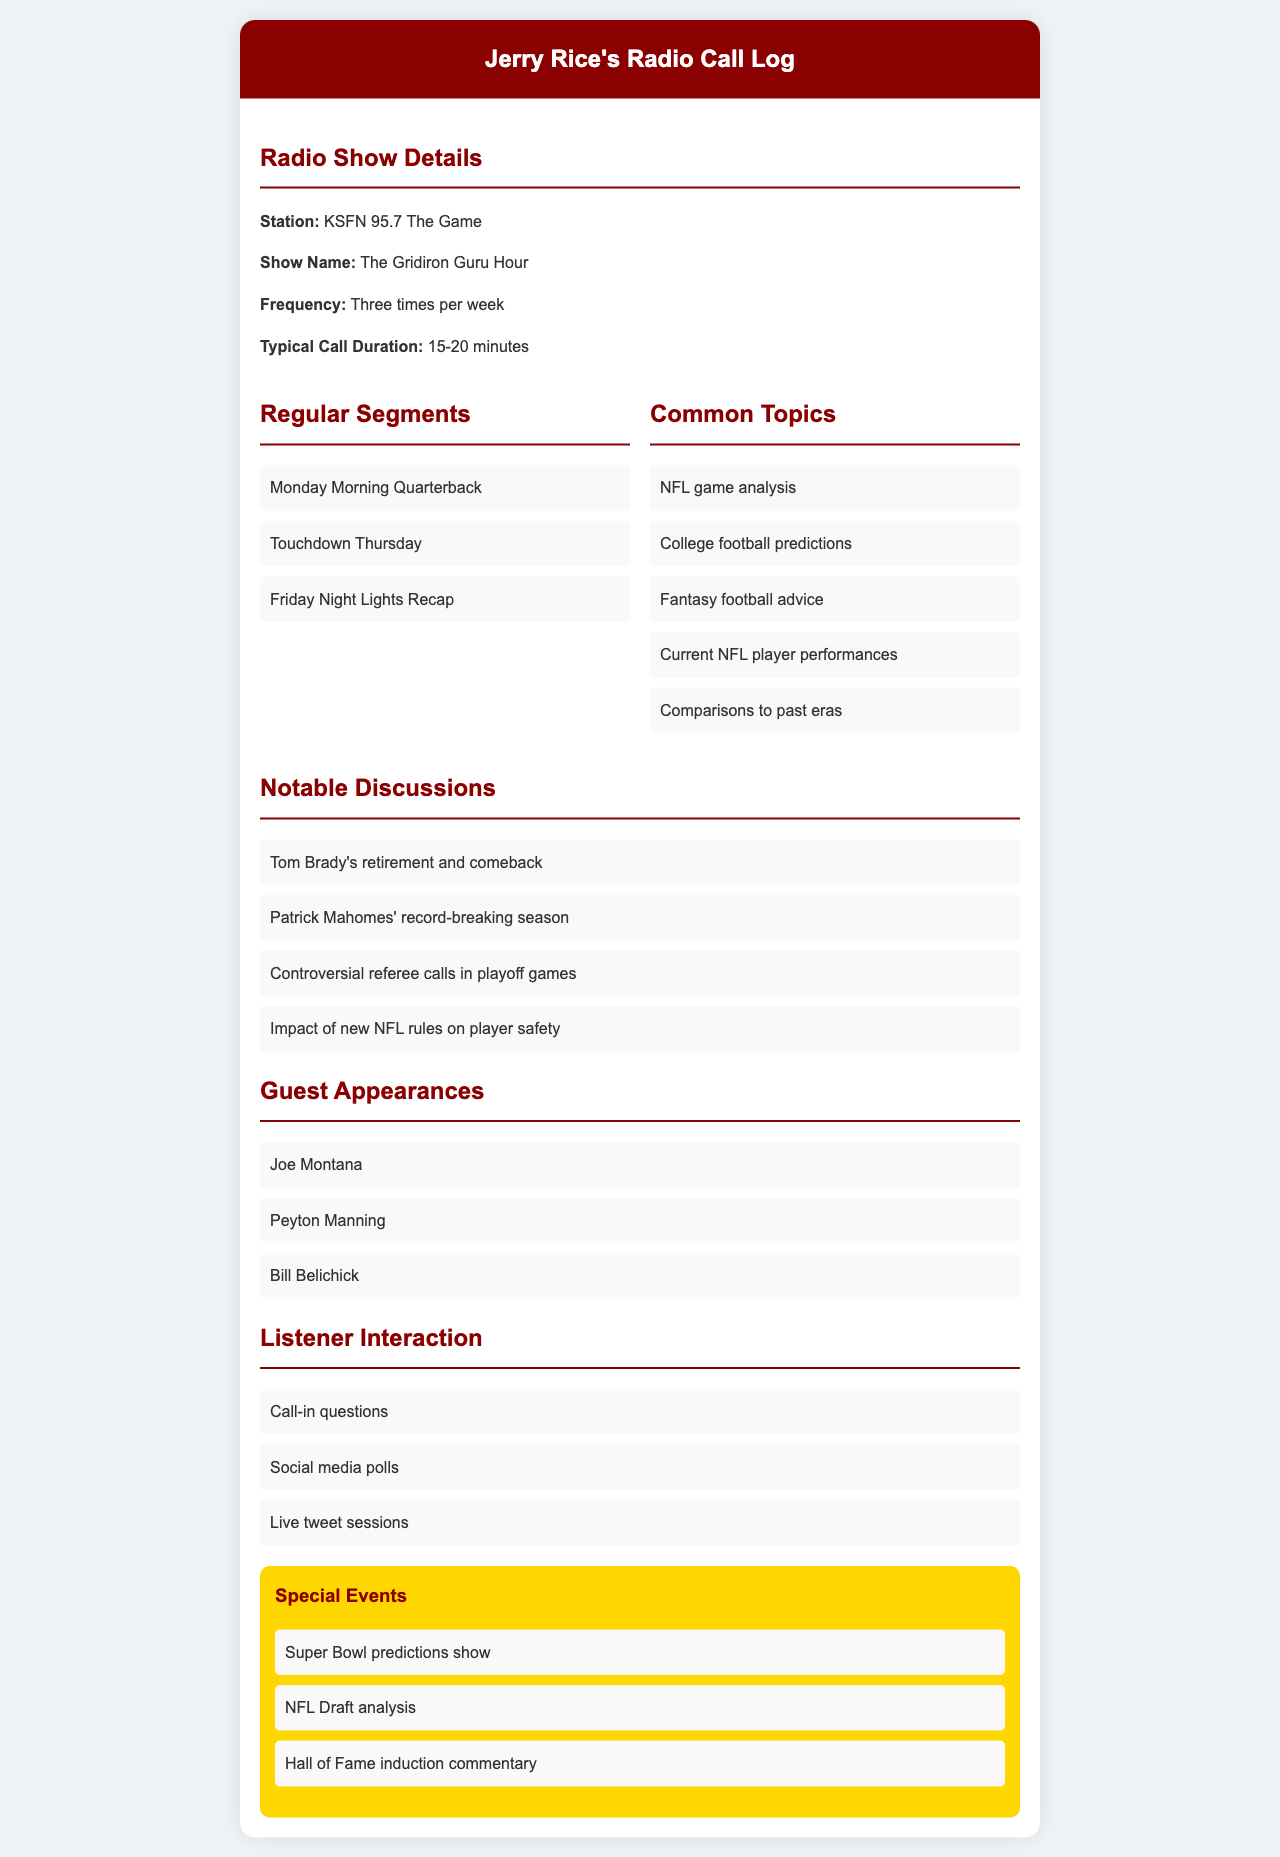What is the name of the radio station? The radio station name is listed prominently in the document.
Answer: KSFN 95.7 The Game How many times per week does the show air? The document states the frequency of the show clearly.
Answer: Three times per week What is the typical call duration? The document provides a specific duration for the calls made.
Answer: 15-20 minutes Name one common topic discussed in the show. The document lists several topics related to football analysis.
Answer: NFL game analysis Who was a guest appearance mentioned? The document includes a list of notable guests with their names.
Answer: Joe Montana What is one special event highlighted in the document? The document lists specific events related to football predictions and analysis.
Answer: Super Bowl predictions show Which segment occurs on Monday? The document lays out the segments for each day, focusing on the Monday segment specifically.
Answer: Monday Morning Quarterback How many notable discussions are listed? The document provides a clear count of notable discussions mentioned.
Answer: Four 